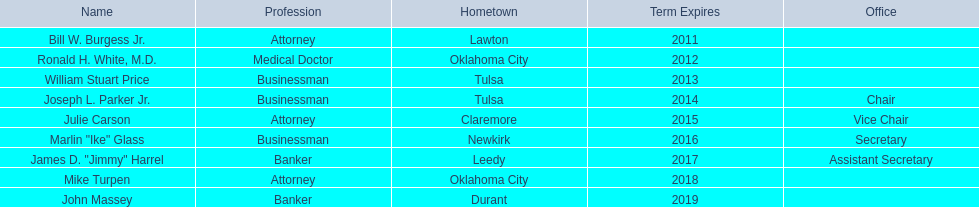Who are the individuals serving as state regents? Bill W. Burgess Jr., Ronald H. White, M.D., William Stuart Price, Joseph L. Parker Jr., Julie Carson, Marlin "Ike" Glass, James D. "Jimmy" Harrel, Mike Turpen, John Massey. Among these state regents, who shares a hometown with ronald h. white, m.d.? Mike Turpen. 